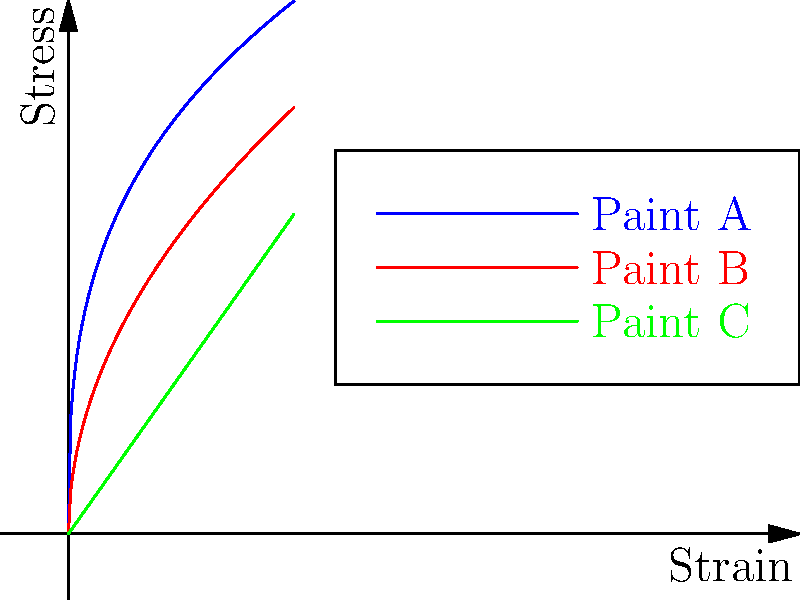As a paint supplier, you're evaluating the durability of three different paint coatings (A, B, and C) for a cafe's outdoor mural project. The stress-strain curves for these paints under various environmental conditions are shown in the graph. Which paint would you recommend for the best overall durability and why? To determine the best paint for durability, we need to analyze the stress-strain curves:

1. Paint A (blue curve): Shows a rapid increase in stress at low strains, then levels off. This indicates:
   - High initial stiffness
   - Good resistance to small deformations
   - Becomes more flexible at higher strains, potentially preventing cracking

2. Paint B (red curve): Demonstrates a more gradual increase in stress with strain. This suggests:
   - Moderate stiffness
   - Consistent behavior across a range of strains
   - Good balance between flexibility and strength

3. Paint C (green curve): Exhibits a linear relationship between stress and strain. This implies:
   - Constant stiffness throughout the strain range
   - Predictable behavior
   - May be prone to sudden failure at high stresses

Comparing the three:
- Paint A offers the best resistance to small deformations but may be too rigid for large environmental changes.
- Paint C provides consistent behavior but lacks the flexibility to accommodate significant environmental stresses.
- Paint B offers a good balance between strength and flexibility, making it suitable for varying environmental conditions.

For an outdoor mural exposed to various environmental factors (temperature changes, humidity, etc.), Paint B would be the best choice. It provides:

1. Sufficient initial strength to resist small deformations
2. Flexibility to accommodate larger environmental stresses without cracking
3. A good balance of properties for long-term durability in changing conditions
Answer: Paint B, due to its balanced stress-strain behavior providing both strength and flexibility for varying environmental conditions. 